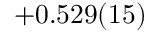Convert formula to latex. <formula><loc_0><loc_0><loc_500><loc_500>+ 0 . 5 2 9 ( 1 5 )</formula> 